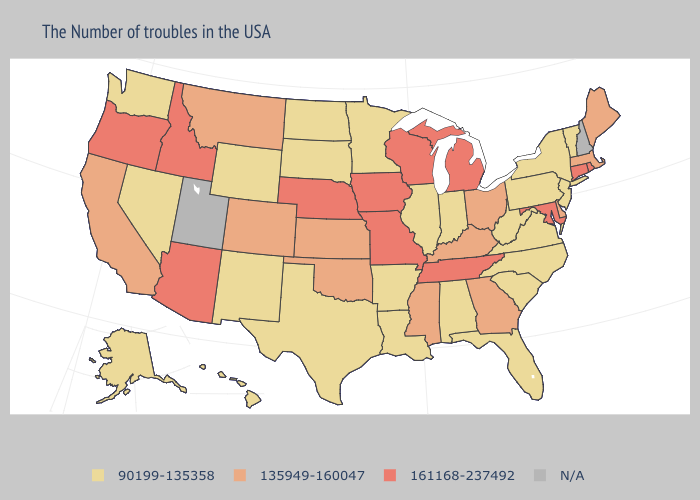What is the highest value in states that border Wisconsin?
Concise answer only. 161168-237492. Which states have the lowest value in the USA?
Be succinct. Vermont, New York, New Jersey, Pennsylvania, Virginia, North Carolina, South Carolina, West Virginia, Florida, Indiana, Alabama, Illinois, Louisiana, Arkansas, Minnesota, Texas, South Dakota, North Dakota, Wyoming, New Mexico, Nevada, Washington, Alaska, Hawaii. What is the value of New Mexico?
Concise answer only. 90199-135358. What is the value of Texas?
Give a very brief answer. 90199-135358. Among the states that border Kansas , which have the lowest value?
Concise answer only. Oklahoma, Colorado. Does Alaska have the highest value in the USA?
Keep it brief. No. Name the states that have a value in the range 161168-237492?
Give a very brief answer. Rhode Island, Connecticut, Maryland, Michigan, Tennessee, Wisconsin, Missouri, Iowa, Nebraska, Arizona, Idaho, Oregon. What is the value of Minnesota?
Be succinct. 90199-135358. Name the states that have a value in the range N/A?
Answer briefly. New Hampshire, Utah. What is the lowest value in the MidWest?
Concise answer only. 90199-135358. Among the states that border Oklahoma , does Missouri have the lowest value?
Concise answer only. No. Name the states that have a value in the range N/A?
Be succinct. New Hampshire, Utah. Does Louisiana have the highest value in the South?
Give a very brief answer. No. 